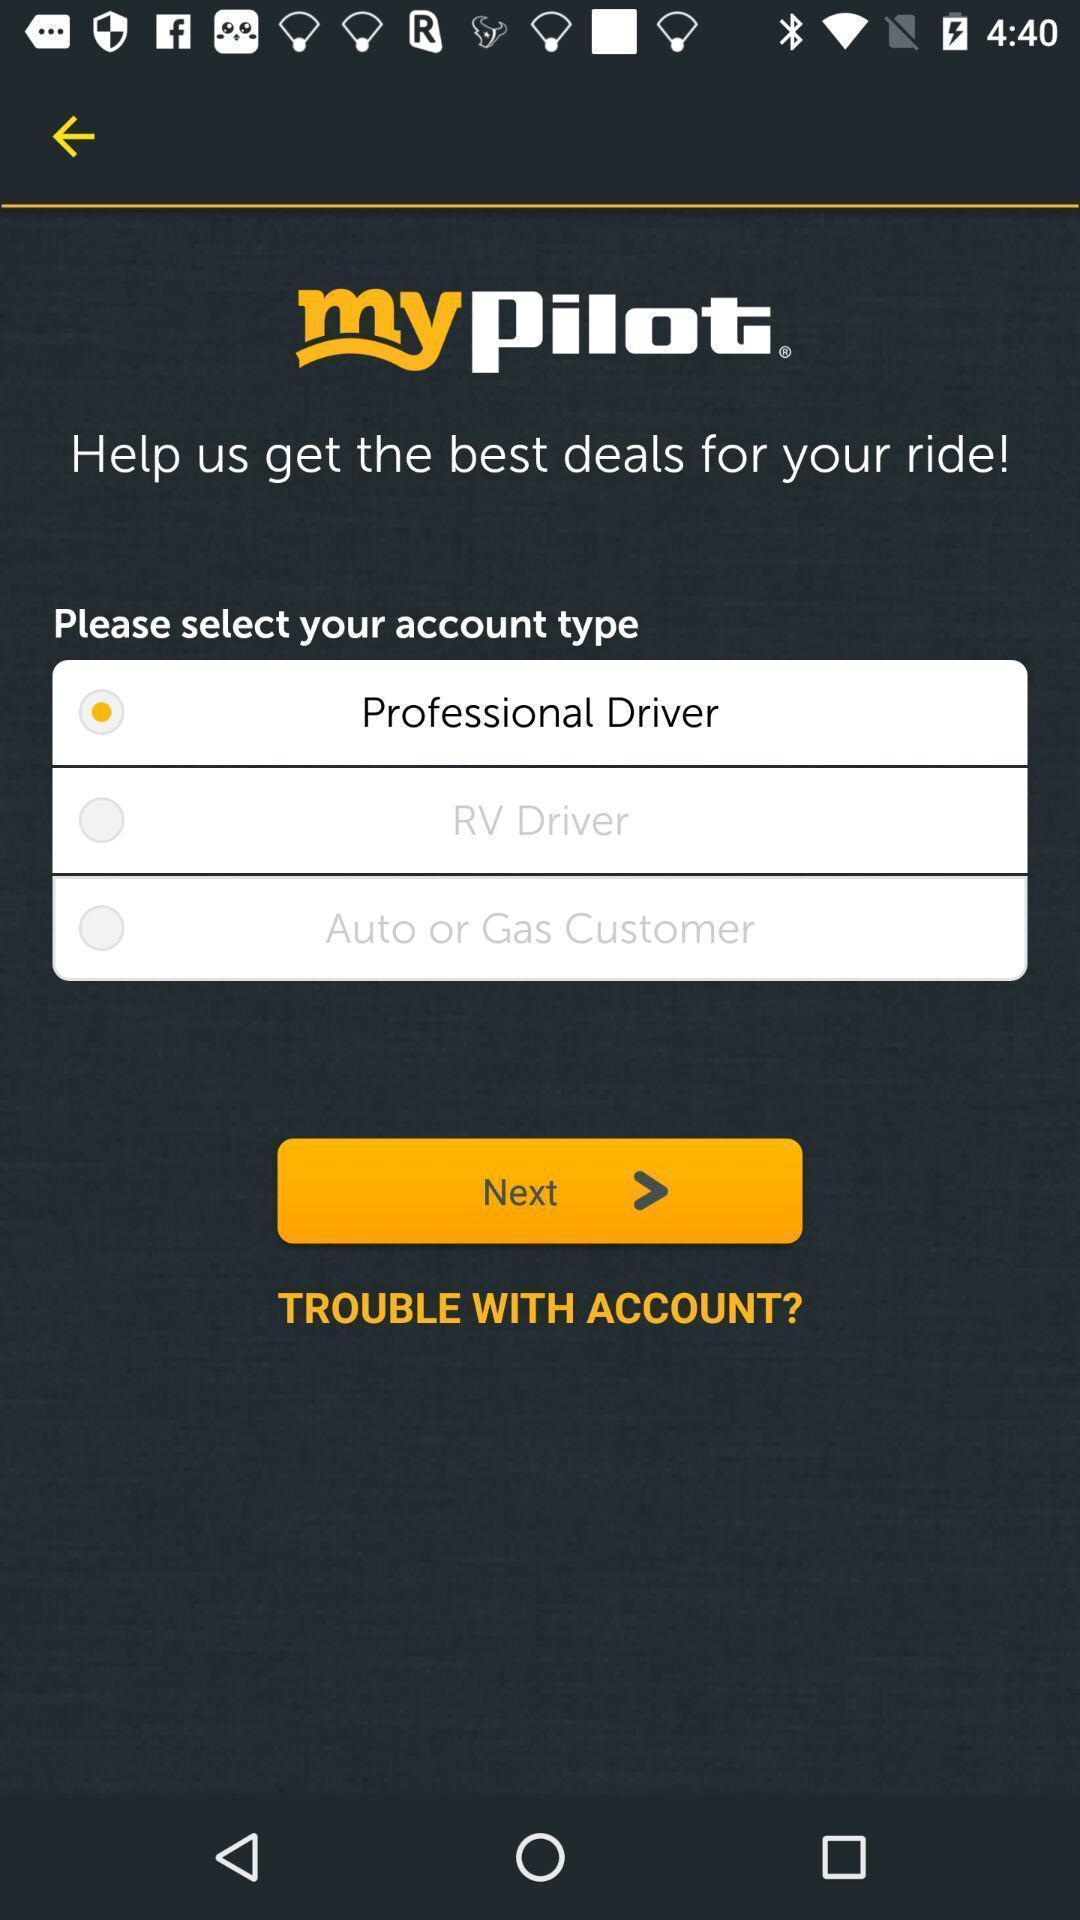Summarize the main components in this picture. Professional driver in the my pilot. 